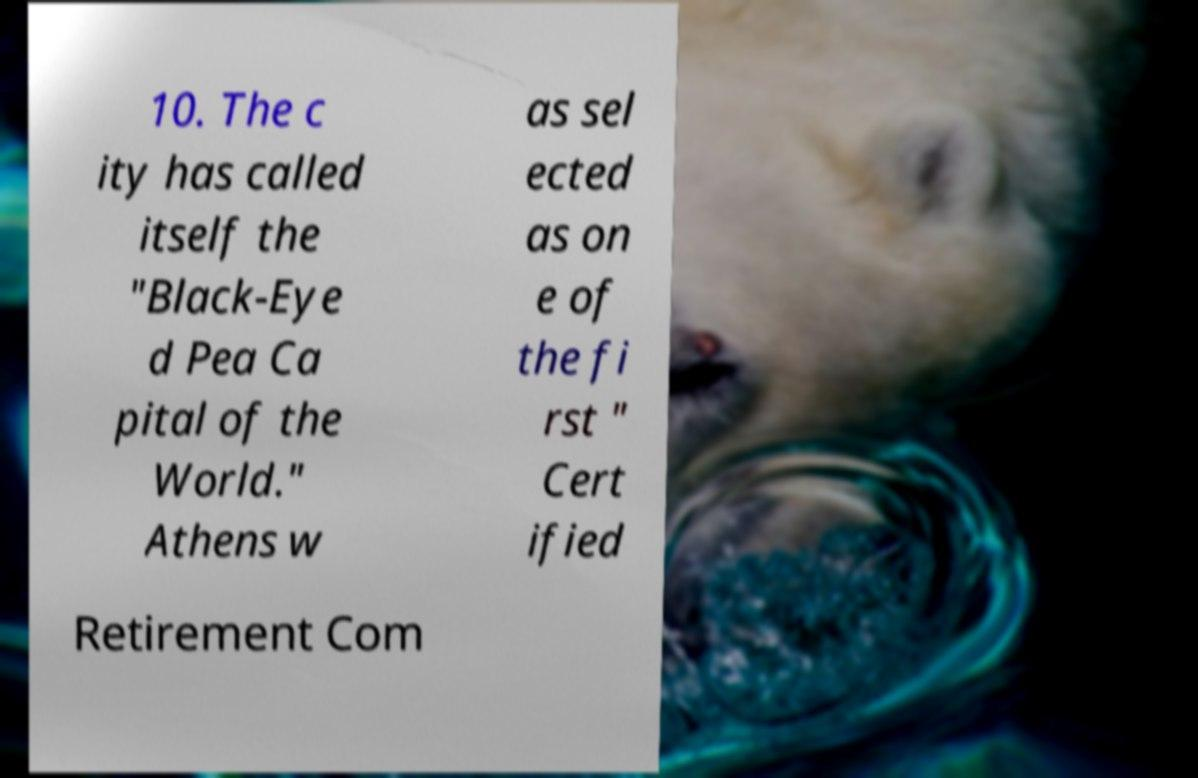I need the written content from this picture converted into text. Can you do that? 10. The c ity has called itself the "Black-Eye d Pea Ca pital of the World." Athens w as sel ected as on e of the fi rst " Cert ified Retirement Com 